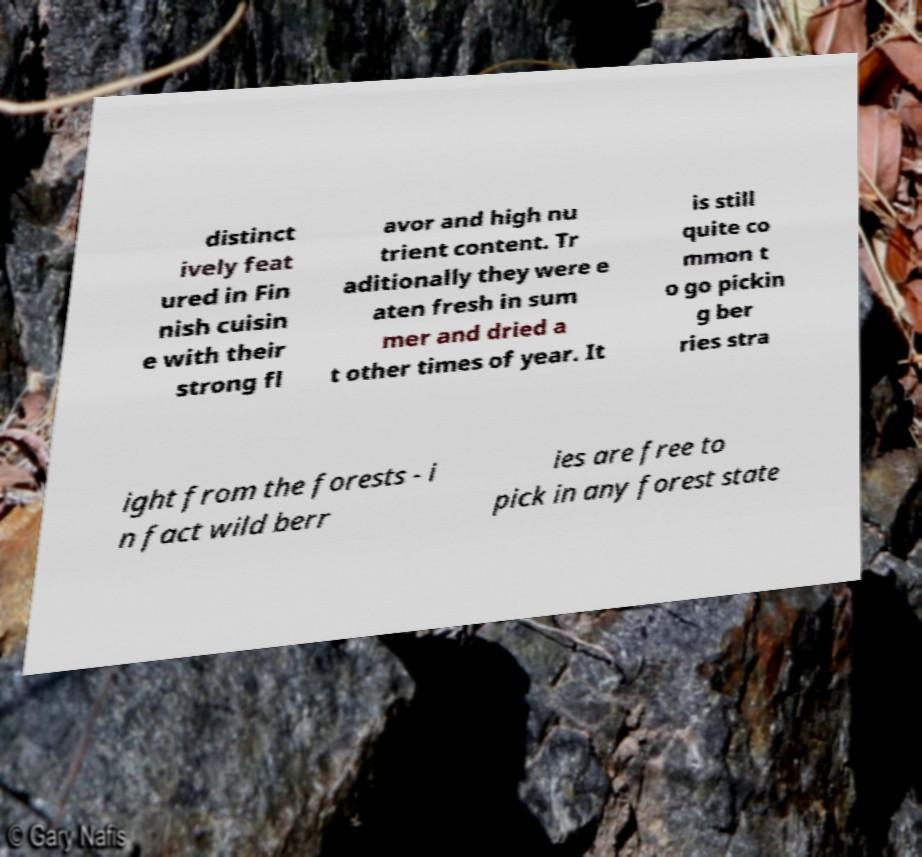Could you extract and type out the text from this image? distinct ively feat ured in Fin nish cuisin e with their strong fl avor and high nu trient content. Tr aditionally they were e aten fresh in sum mer and dried a t other times of year. It is still quite co mmon t o go pickin g ber ries stra ight from the forests - i n fact wild berr ies are free to pick in any forest state 